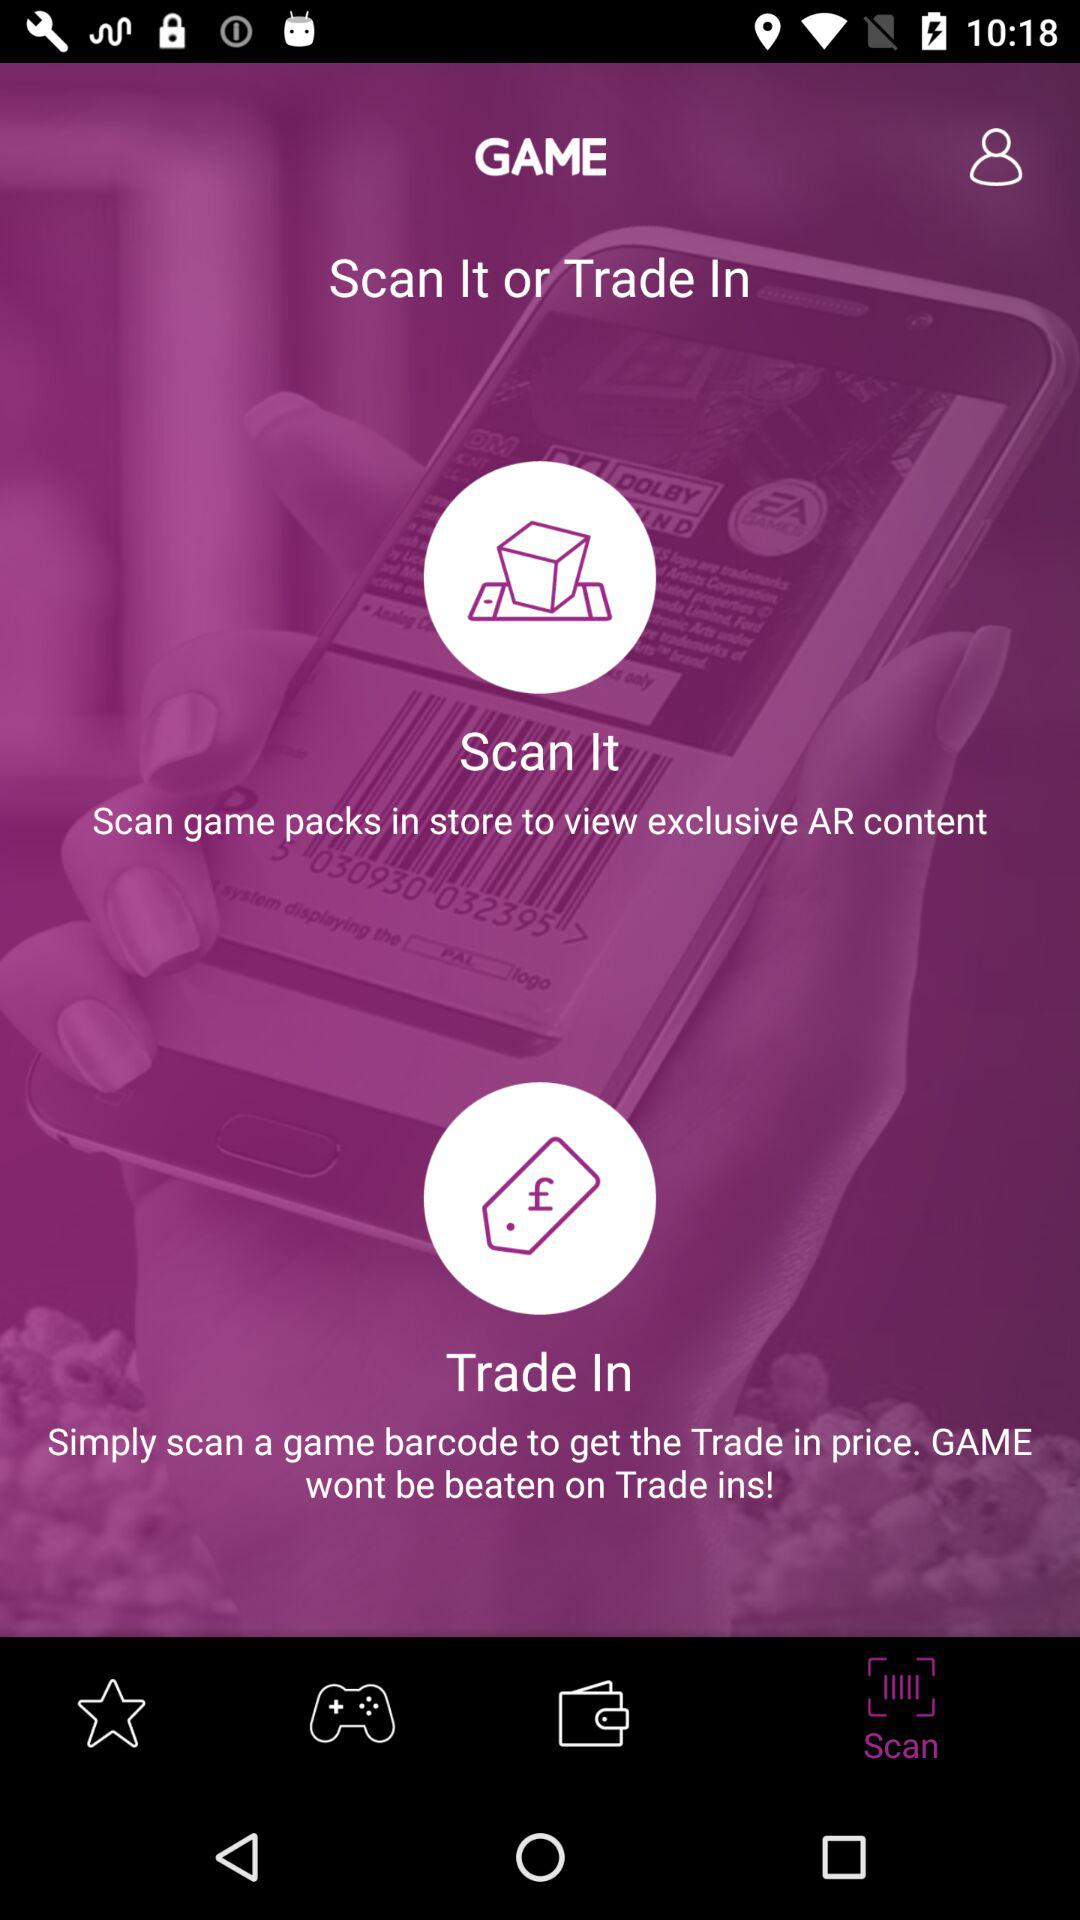Which tab is selected? The selected tab is "Scan". 